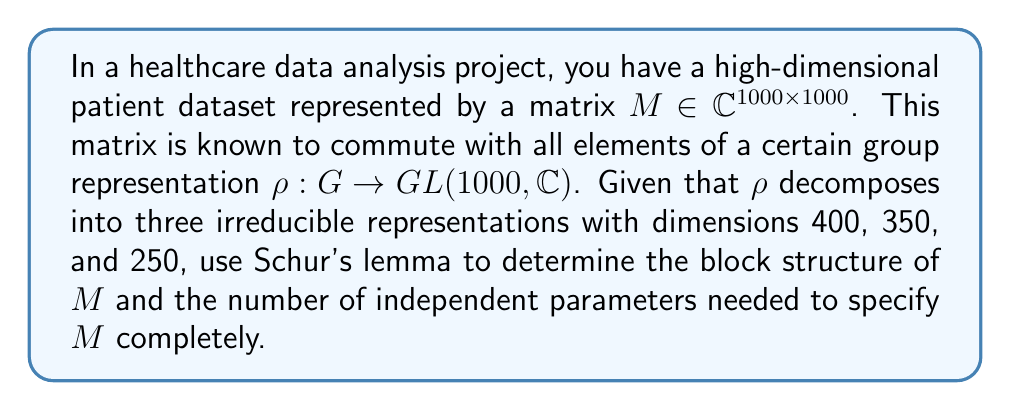Could you help me with this problem? 1) Schur's lemma states that if a matrix $M$ commutes with all elements of an irreducible representation, then $M$ must be a scalar multiple of the identity matrix.

2) Given that $\rho$ decomposes into three irreducible representations, we can write:

   $$\rho \cong \rho_1 \oplus \rho_2 \oplus \rho_3$$

   where $\dim(\rho_1) = 400$, $\dim(\rho_2) = 350$, and $\dim(\rho_3) = 250$.

3) Since $M$ commutes with all elements of $\rho$, it must have the following block diagonal form:

   $$M = \begin{pmatrix}
   \lambda_1 I_{400} & 0 & 0 \\
   0 & \lambda_2 I_{350} & 0 \\
   0 & 0 & \lambda_3 I_{250}
   \end{pmatrix}$$

   where $I_n$ denotes the $n \times n$ identity matrix and $\lambda_1, \lambda_2, \lambda_3 \in \mathbb{C}$.

4) The block structure of $M$ consists of three blocks:
   - A $400 \times 400$ block
   - A $350 \times 350$ block
   - A $250 \times 250$ block

5) Each block is a scalar multiple of the identity matrix, so we need only one complex number to specify each block.

6) Therefore, the total number of independent parameters needed to specify $M$ completely is 3 complex numbers, or equivalently, 6 real numbers (3 for the real parts and 3 for the imaginary parts).
Answer: 3 blocks; 3 complex parameters 